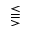<formula> <loc_0><loc_0><loc_500><loc_500>\leq s s e q q g t r</formula> 